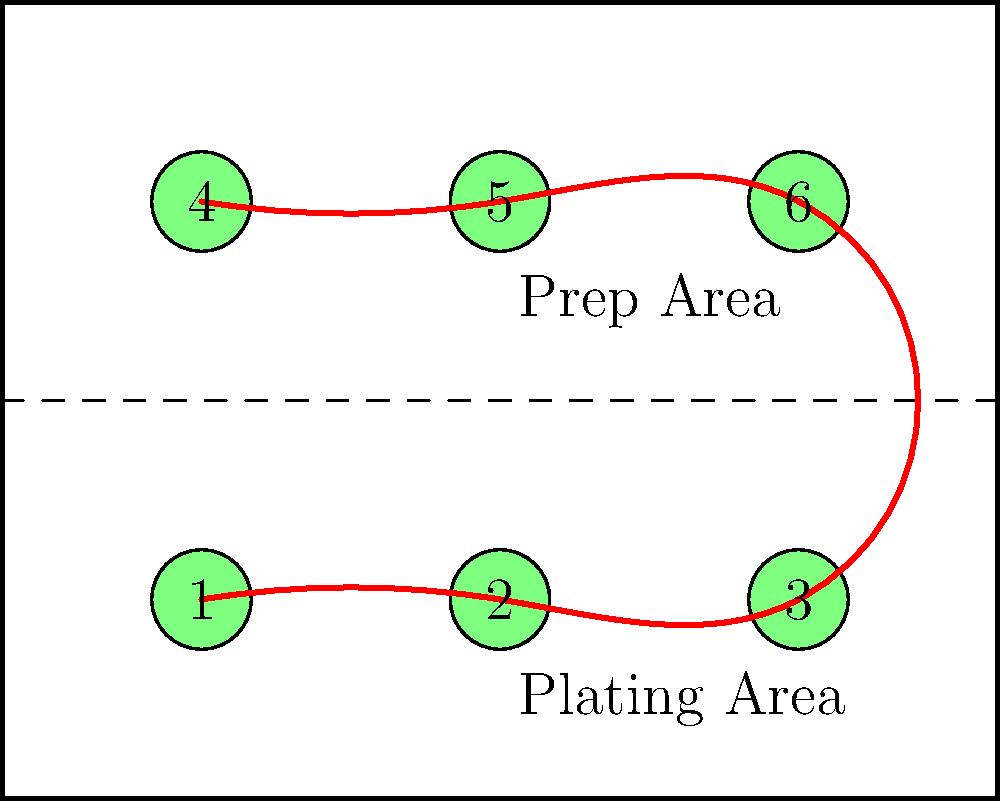In the commercial kitchen layout shown above, the chef needs to visit all six cooking stations in the most efficient order. The stations are numbered 1 to 6. What is the optimal path for the chef to minimize walking distance, assuming they start and end at station 1? To find the most efficient path, we need to consider the layout and minimize the total distance traveled. Let's analyze the problem step-by-step:

1. The cooking stations are arranged in two rows of three stations each.
2. The chef starts at station 1.
3. To minimize walking distance, the chef should visit adjacent stations whenever possible.
4. The prep area is in the middle, separating the two rows of stations.

Considering these factors, we can determine the optimal path:

1. Start at station 1
2. Move to station 2 (adjacent)
3. Move to station 3 (adjacent)
4. Cross the prep area to station 6 (closest station in the upper row)
5. Move to station 5 (adjacent)
6. Move to station 4 (adjacent)
7. Return to station 1 to complete the circuit

This path minimizes the number of times the chef needs to cross the prep area (only once) and ensures they always move to the nearest unvisited station.

The optimal path can be represented as: 1 → 2 → 3 → 6 → 5 → 4 → 1

This route forms a roughly rectangular path, which is often the most efficient way to cover all stations in a grid-like layout.
Answer: 1 → 2 → 3 → 6 → 5 → 4 → 1 